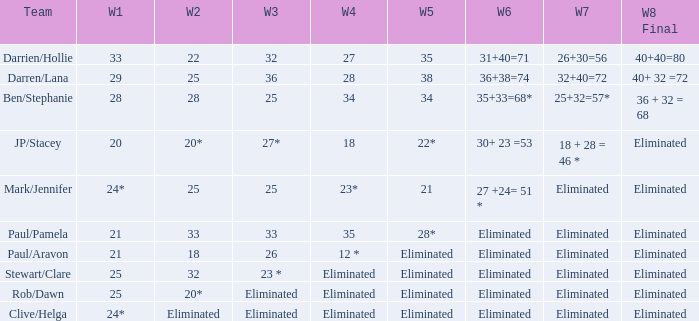Name the team for week 1 of 28 Ben/Stephanie. 